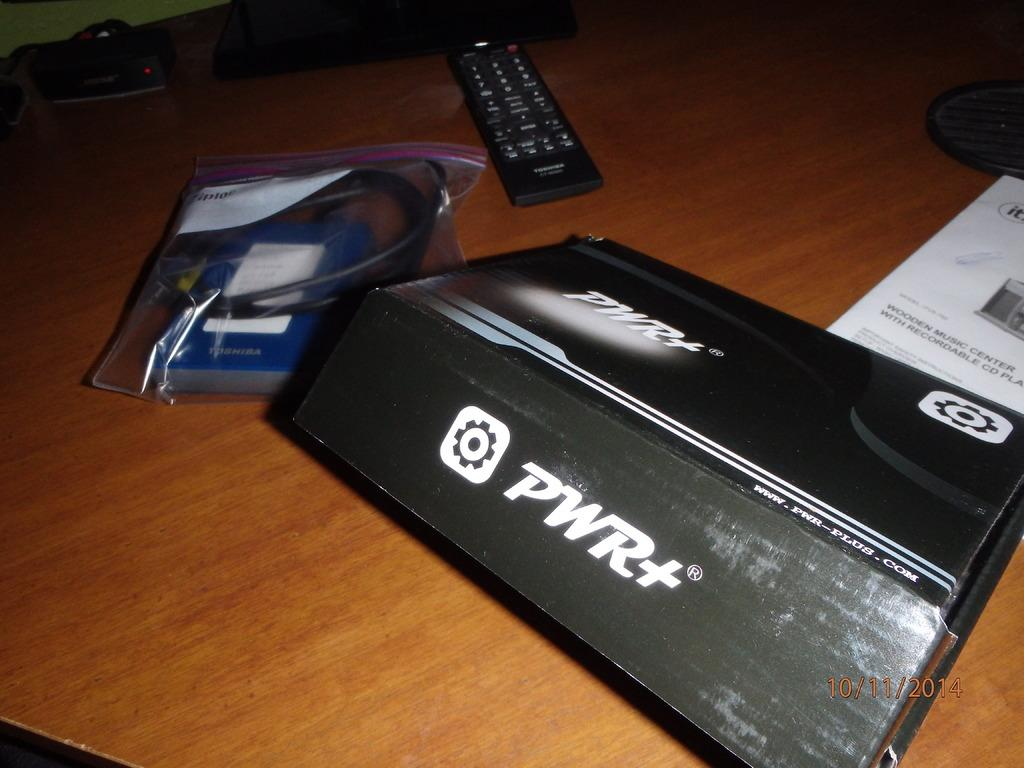<image>
Create a compact narrative representing the image presented. Box for a PWR+ sits on a table next to directions and a remote 